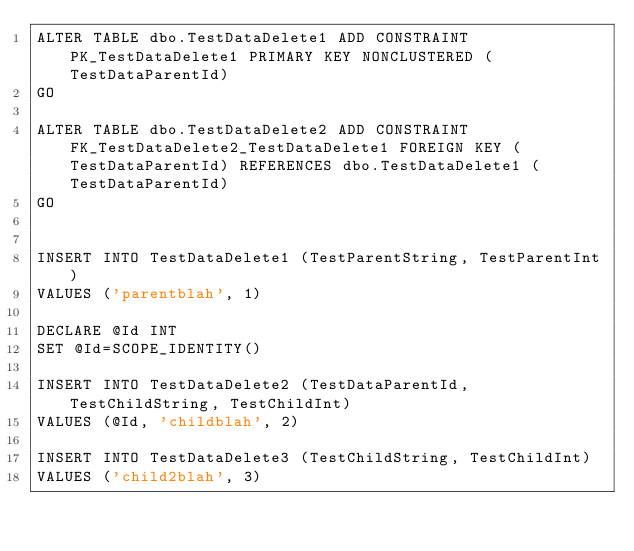<code> <loc_0><loc_0><loc_500><loc_500><_SQL_>ALTER TABLE dbo.TestDataDelete1 ADD CONSTRAINT PK_TestDataDelete1 PRIMARY KEY NONCLUSTERED (TestDataParentId)
GO

ALTER TABLE dbo.TestDataDelete2 ADD CONSTRAINT FK_TestDataDelete2_TestDataDelete1 FOREIGN KEY (TestDataParentId) REFERENCES dbo.TestDataDelete1 (TestDataParentId)
GO


INSERT INTO TestDataDelete1 (TestParentString, TestParentInt)
VALUES ('parentblah', 1)

DECLARE @Id INT
SET @Id=SCOPE_IDENTITY()

INSERT INTO TestDataDelete2 (TestDataParentId, TestChildString, TestChildInt)
VALUES (@Id, 'childblah', 2)

INSERT INTO TestDataDelete3 (TestChildString, TestChildInt)
VALUES ('child2blah', 3)


</code> 